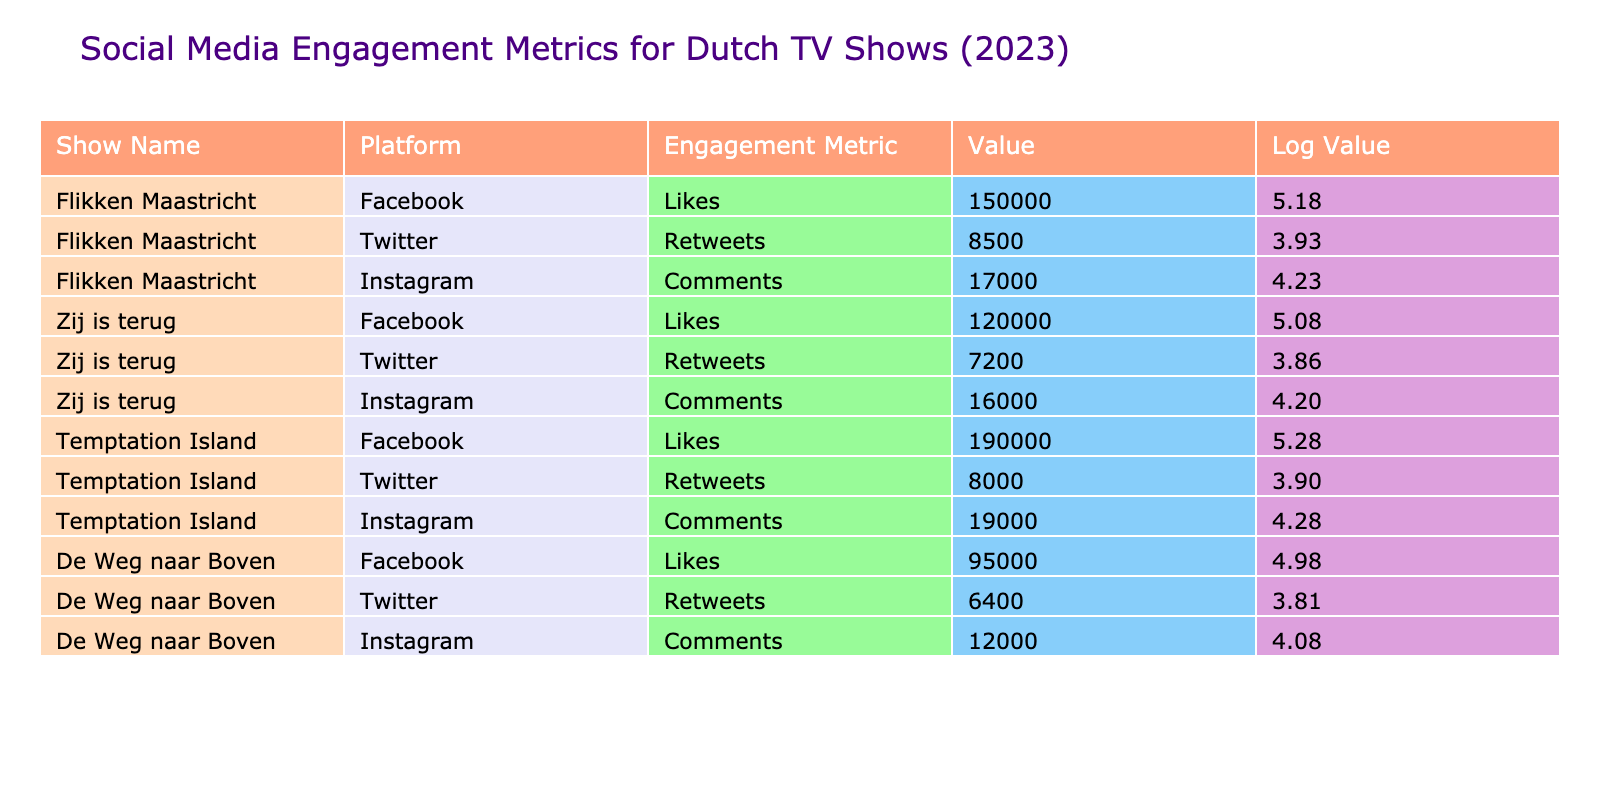What is the engagement metric with the highest value for "Temptation Island"? Looking at the "Temptation Island" row, the engagement metrics are Likes (190000), Retweets (8000), and Comments (19000). The highest value is for Likes.
Answer: Likes How many total likes did "Flikken Maastricht" receive across all platforms? "Flikken Maastricht" has 150000 Likes on Facebook, 0 Likes on Twitter, and 0 Likes on Instagram. The total Likes for "Flikken Maastricht" is 150000 + 0 + 0 = 150000.
Answer: 150000 Which platform had the most comments for "Zij is terug"? In "Zij is terug", the engagement metrics regarding comments are: Facebook (0), Twitter (0), Instagram (16000). Since Instagram has the highest comments count, the answer is Instagram.
Answer: Instagram Is the average retweet count for the shows more than 7000? To find the average retweet count, sum the retweets for each show: Flikken Maastricht (8500) + Zij is terug (7200) + Temptation Island (8000) + De Weg naar Boven (6400) = 30100. Then divide by the number of shows (4): 30100 / 4 = 7525. The average is indeed more than 7000.
Answer: Yes Which show has the lowest Instagram comments? Looking through the Instagram comments, "De Weg naar Boven" has 12000 comments, "Zij is terug" has 16000, "Flikken Maastricht" has 17000, and "Temptation Island" has 19000. Hence, the lowest Instagram comments are for "De Weg naar Boven."
Answer: De Weg naar Boven What is the difference in the number of likes between "Temptation Island" and "Zij is terug"? "Temptation Island" has 190000 Likes and "Zij is terug" has 120000 Likes. The difference is calculated as 190000 - 120000 = 70000.
Answer: 70000 Does "Flikken Maastricht" have more Retweets than "De Weg naar Boven"? "Flikken Maastricht" has 8500 Retweets while "De Weg naar Boven" has 6400 Retweets. Since 8500 is greater than 6400, the answer is yes.
Answer: Yes Which show had the highest engagement on Facebook based on Likes? Analyzing the Likes for Facebook: "Flikken Maastricht" (150000), "Zij is terug" (120000), "Temptation Island" (190000), and "De Weg naar Boven" (95000). "Temptation Island" has the highest Likes among the shows.
Answer: Temptation Island What is the average engagement metric value across all platforms for "De Weg naar Boven"? The values for "De Weg naar Boven" are Likes (95000), Retweets (6400), and Comments (12000). The total is 95000 + 6400 + 12000 = 113400, and then divided by 3 gives the average: 113400 / 3 = 37800.
Answer: 37800 